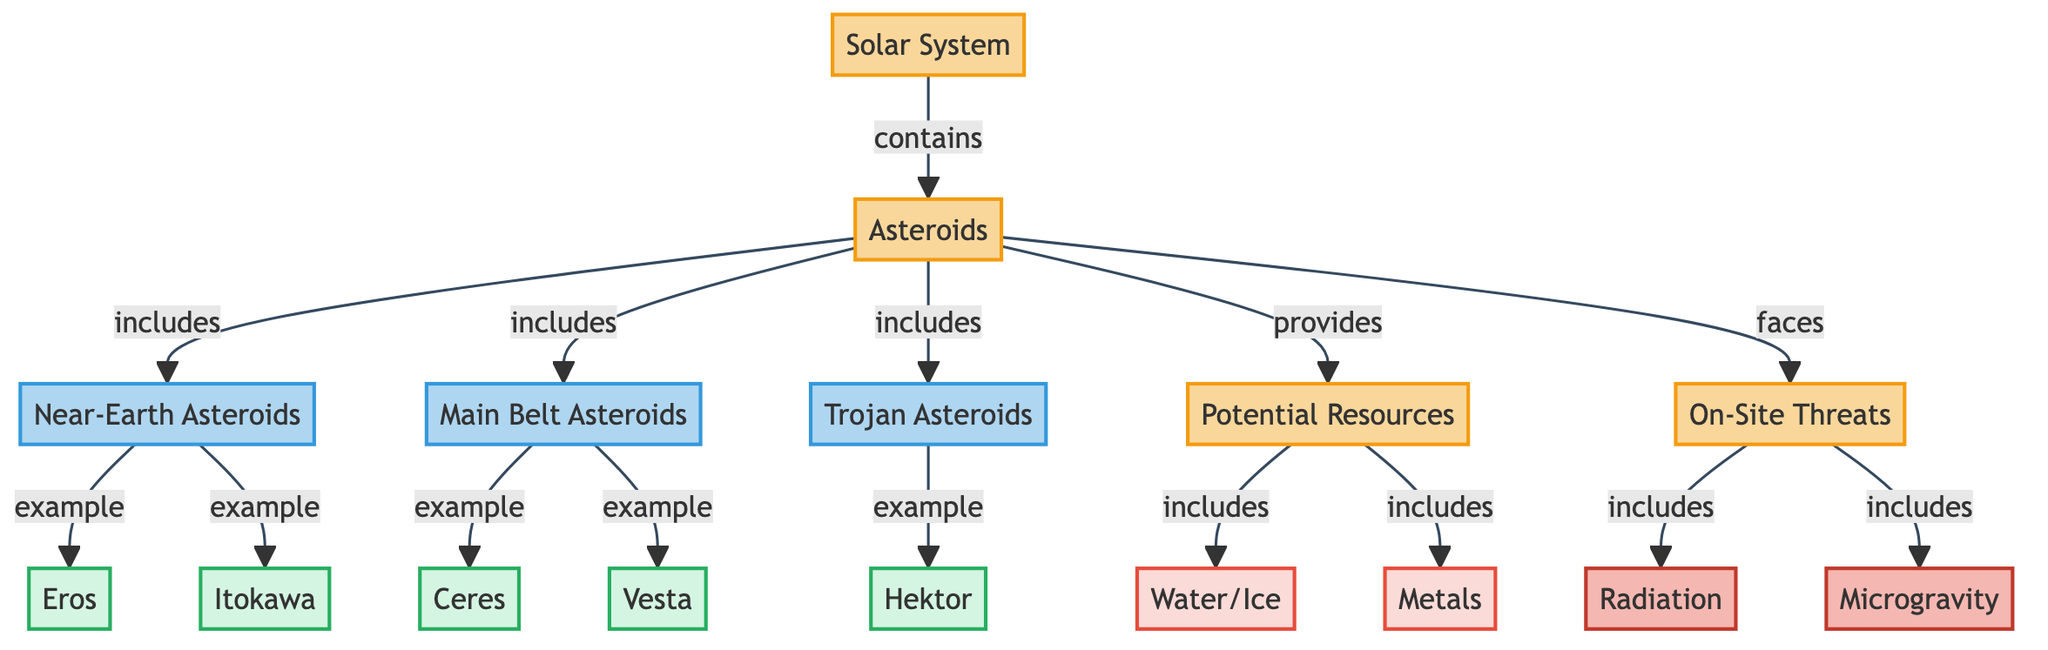What are the three categories of asteroids shown in the diagram? The diagram explicitly defines three categories of asteroids, which are Near-Earth Asteroids, Main Belt Asteroids, and Trojan Asteroids. These are indicated as subcategories directly connected to the Asteroids node.
Answer: Near-Earth Asteroids, Main Belt Asteroids, Trojan Asteroids Which asteroid is an example of Main Belt Asteroids? The diagram shows that both Ceres and Vesta are categorized as examples of Main Belt Asteroids, as indicated in the relationship arrows leading from Main Belt Asteroids to these two nodes.
Answer: Ceres, Vesta How many threats to colonization are identified in the diagram? In the diagram, there are two threats classified under On-Site Threats: Radiation and Microgravity. Therefore, by counting these specific nodes, the total number of threats is determined.
Answer: 2 Which resource is included as a potential resource from asteroids? Among the potential resources categorized in the diagram, Water/Ice is shown as one of the key resources that asteroids can provide. It is directly listed under the Potential Resources category linked to the Asteroids node.
Answer: Water/Ice What is the relationship between Asteroids and Potential Resources? The diagram states that Asteroids provide Potential Resources, which is represented by the directional arrow from the Asteroids node to the Potential Resources node, indicating a direct connection and provision of these resources.
Answer: provides What types of asteroids are examples of Near-Earth Asteroids? The diagram specifies that Eros and Itokawa are provided as examples of Near-Earth Asteroids, as indicated next to the Near-Earth Asteroids node with example relationship arrows pointing to these two nodes.
Answer: Eros, Itokawa What type of diagram is represented, and what is its primary focus? The diagram is categorized as an Astronomy Diagram, with its primary focus on the Distribution of Asteroids in the Solar System, highlighting their potential for future colonization and the associated resources and threats.
Answer: Astronomy Diagram How many main categories are depicted in the diagram? The diagram presents four main categories visible through the use of distinct color coding and naming, which include the Solar System, Asteroids, Potential Resources, and On-Site Threats. Counting these categories gives the total.
Answer: 4 